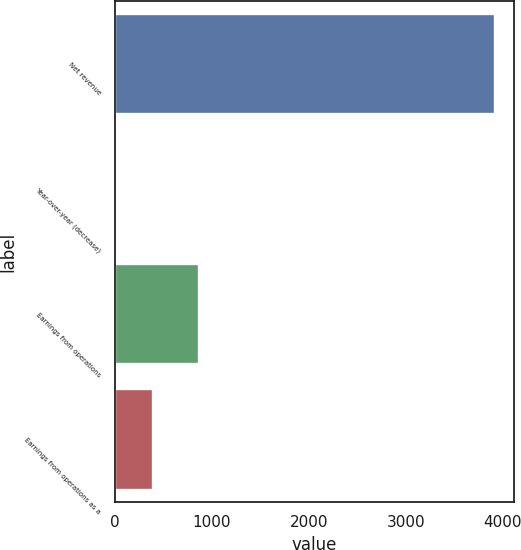Convert chart. <chart><loc_0><loc_0><loc_500><loc_500><bar_chart><fcel>Net revenue<fcel>Year-over-year (decrease)<fcel>Earnings from operations<fcel>Earnings from operations as a<nl><fcel>3913<fcel>3.6<fcel>866<fcel>394.54<nl></chart> 